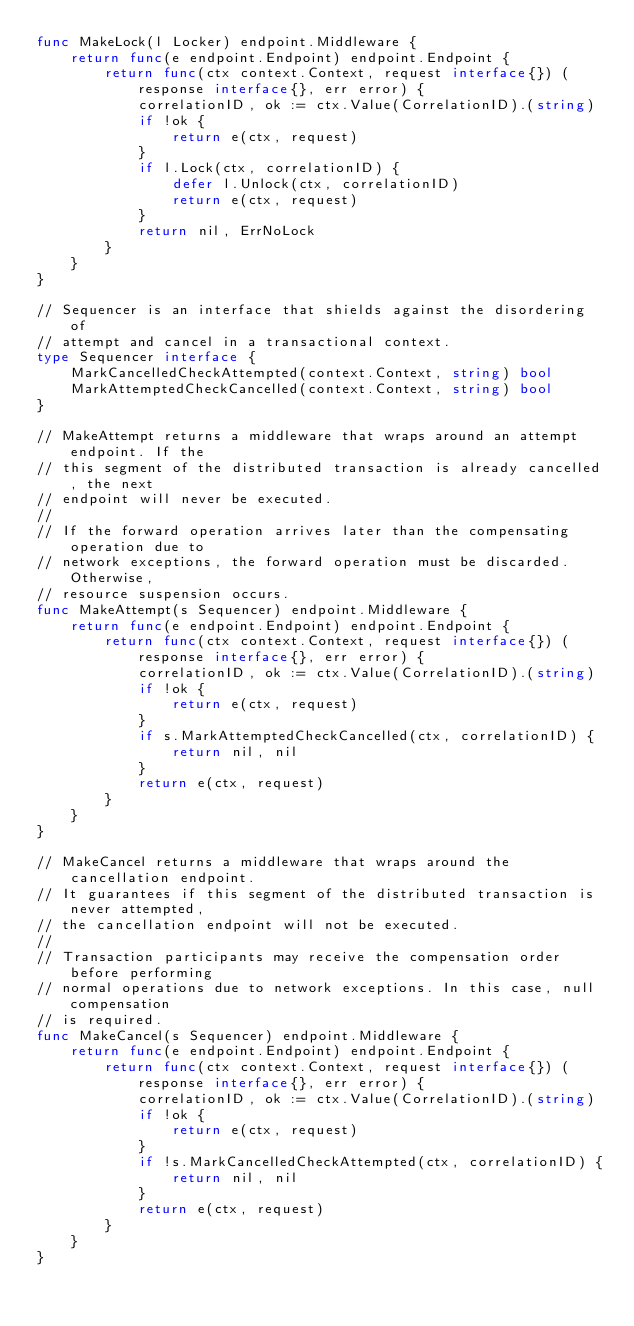Convert code to text. <code><loc_0><loc_0><loc_500><loc_500><_Go_>func MakeLock(l Locker) endpoint.Middleware {
	return func(e endpoint.Endpoint) endpoint.Endpoint {
		return func(ctx context.Context, request interface{}) (response interface{}, err error) {
			correlationID, ok := ctx.Value(CorrelationID).(string)
			if !ok {
				return e(ctx, request)
			}
			if l.Lock(ctx, correlationID) {
				defer l.Unlock(ctx, correlationID)
				return e(ctx, request)
			}
			return nil, ErrNoLock
		}
	}
}

// Sequencer is an interface that shields against the disordering of
// attempt and cancel in a transactional context.
type Sequencer interface {
	MarkCancelledCheckAttempted(context.Context, string) bool
	MarkAttemptedCheckCancelled(context.Context, string) bool
}

// MakeAttempt returns a middleware that wraps around an attempt endpoint. If the
// this segment of the distributed transaction is already cancelled, the next
// endpoint will never be executed.
//
// If the forward operation arrives later than the compensating operation due to
// network exceptions, the forward operation must be discarded. Otherwise,
// resource suspension occurs.
func MakeAttempt(s Sequencer) endpoint.Middleware {
	return func(e endpoint.Endpoint) endpoint.Endpoint {
		return func(ctx context.Context, request interface{}) (response interface{}, err error) {
			correlationID, ok := ctx.Value(CorrelationID).(string)
			if !ok {
				return e(ctx, request)
			}
			if s.MarkAttemptedCheckCancelled(ctx, correlationID) {
				return nil, nil
			}
			return e(ctx, request)
		}
	}
}

// MakeCancel returns a middleware that wraps around the cancellation endpoint.
// It guarantees if this segment of the distributed transaction is never attempted,
// the cancellation endpoint will not be executed.
//
// Transaction participants may receive the compensation order before performing
// normal operations due to network exceptions. In this case, null compensation
// is required.
func MakeCancel(s Sequencer) endpoint.Middleware {
	return func(e endpoint.Endpoint) endpoint.Endpoint {
		return func(ctx context.Context, request interface{}) (response interface{}, err error) {
			correlationID, ok := ctx.Value(CorrelationID).(string)
			if !ok {
				return e(ctx, request)
			}
			if !s.MarkCancelledCheckAttempted(ctx, correlationID) {
				return nil, nil
			}
			return e(ctx, request)
		}
	}
}
</code> 